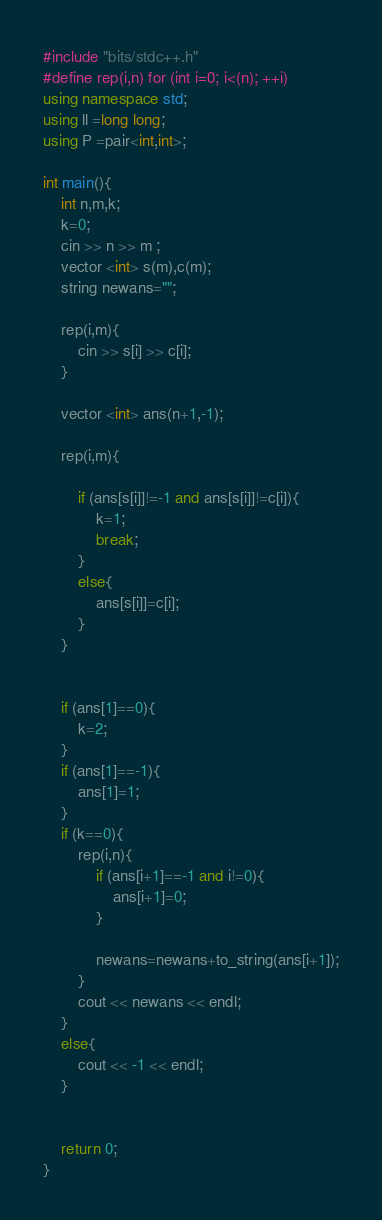<code> <loc_0><loc_0><loc_500><loc_500><_C++_>#include "bits/stdc++.h"
#define rep(i,n) for (int i=0; i<(n); ++i)
using namespace std;
using ll =long long;
using P =pair<int,int>;

int main(){
    int n,m,k;
    k=0;
    cin >> n >> m ;
    vector <int> s(m),c(m);
    string newans="";
    
    rep(i,m){
        cin >> s[i] >> c[i];
    }

    vector <int> ans(n+1,-1);

    rep(i,m){
        
        if (ans[s[i]]!=-1 and ans[s[i]]!=c[i]){
            k=1;
            break;
        }
        else{
            ans[s[i]]=c[i];
        }
    }

    
    if (ans[1]==0){
        k=2;
    }
    if (ans[1]==-1){
        ans[1]=1;
    }
    if (k==0){
        rep(i,n){
            if (ans[i+1]==-1 and i!=0){
                ans[i+1]=0;
            }
            
            newans=newans+to_string(ans[i+1]);
        }
        cout << newans << endl;
    }
    else{
        cout << -1 << endl;
    }
    

    return 0;
}</code> 